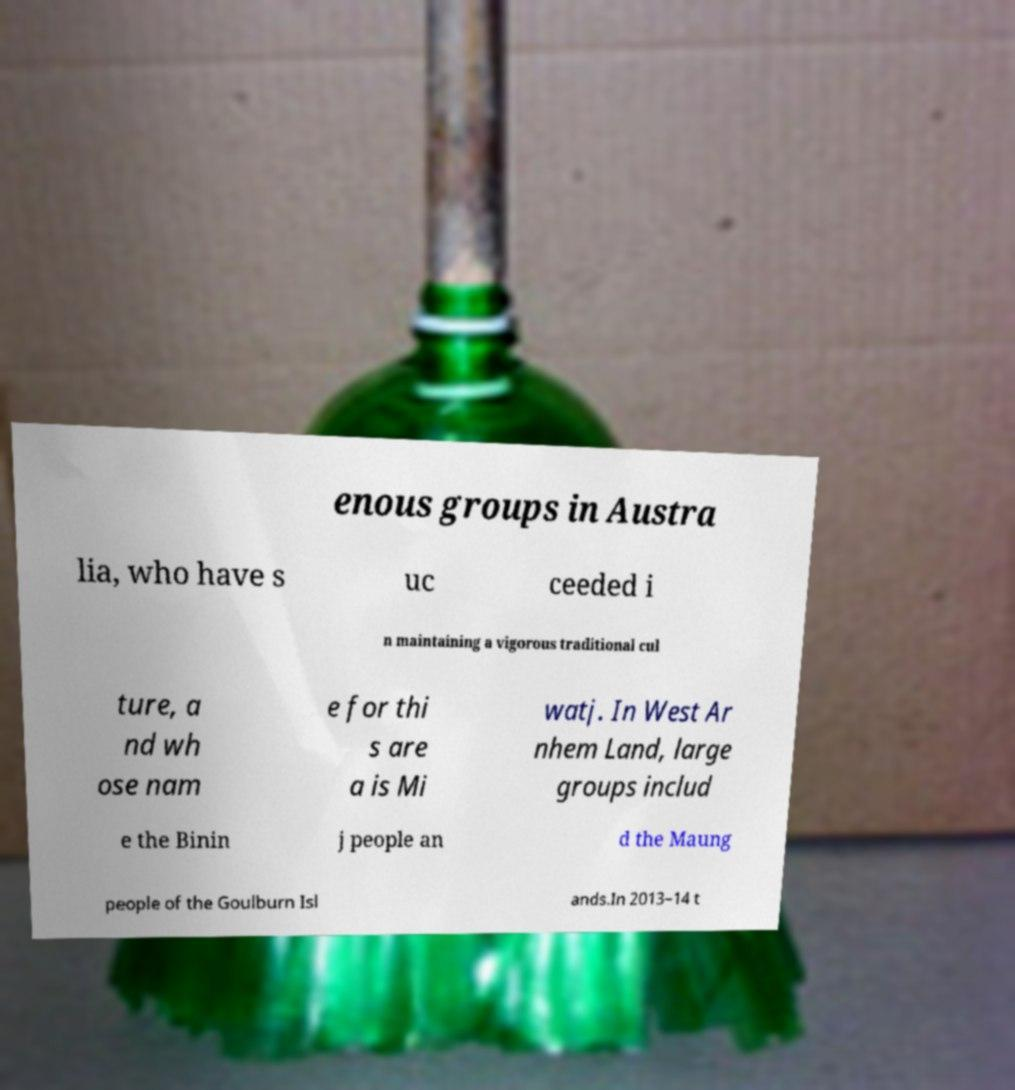Can you accurately transcribe the text from the provided image for me? enous groups in Austra lia, who have s uc ceeded i n maintaining a vigorous traditional cul ture, a nd wh ose nam e for thi s are a is Mi watj. In West Ar nhem Land, large groups includ e the Binin j people an d the Maung people of the Goulburn Isl ands.In 2013–14 t 